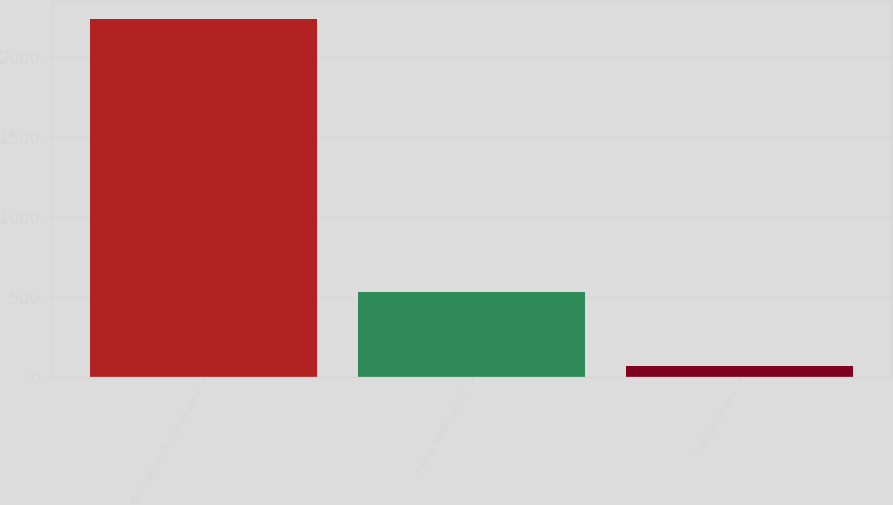Convert chart. <chart><loc_0><loc_0><loc_500><loc_500><bar_chart><fcel>Defi ned benefit pension plans<fcel>Retiree health benefi t<fcel>Medicare rebates<nl><fcel>2234<fcel>530<fcel>69<nl></chart> 